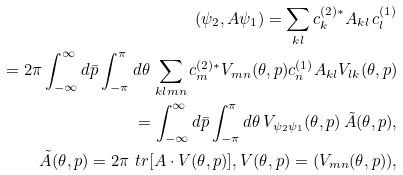<formula> <loc_0><loc_0><loc_500><loc_500>( \psi _ { 2 } , A \psi _ { 1 } ) = \sum _ { k l } c _ { k } ^ { ( 2 ) \ast } A _ { k l } \, c _ { l } ^ { ( 1 ) } \\ = 2 \pi \int _ { - \infty } ^ { \infty } d \bar { p } \int _ { - \pi } ^ { \pi } d \theta \, \sum _ { k l m n } c _ { m } ^ { ( 2 ) \ast } V _ { m n } ( \theta , p ) c _ { n } ^ { ( 1 ) } A _ { k l } V _ { l k } ( \theta , p ) \\ = \int _ { - \infty } ^ { \infty } d \bar { p } \int _ { - \pi } ^ { \pi } d \theta \, V _ { \psi _ { 2 } \psi _ { 1 } } ( \theta , p ) \, \tilde { A } ( \theta , p ) , \\ \tilde { A } ( \theta , p ) = 2 \pi \ t r [ A \cdot V ( \theta , p ) ] , V ( \theta , p ) = ( V _ { m n } ( \theta , p ) ) ,</formula> 